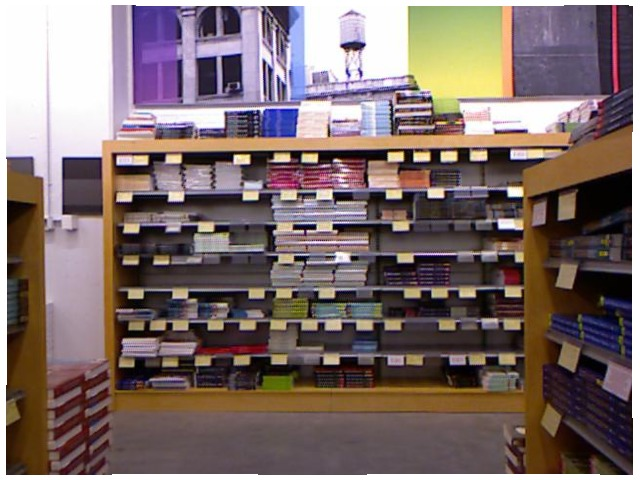<image>
Is the book on the shelf? Yes. Looking at the image, I can see the book is positioned on top of the shelf, with the shelf providing support. Is the water tower above the book? Yes. The water tower is positioned above the book in the vertical space, higher up in the scene. Is there a books in the bookshelves? No. The books is not contained within the bookshelves. These objects have a different spatial relationship. 